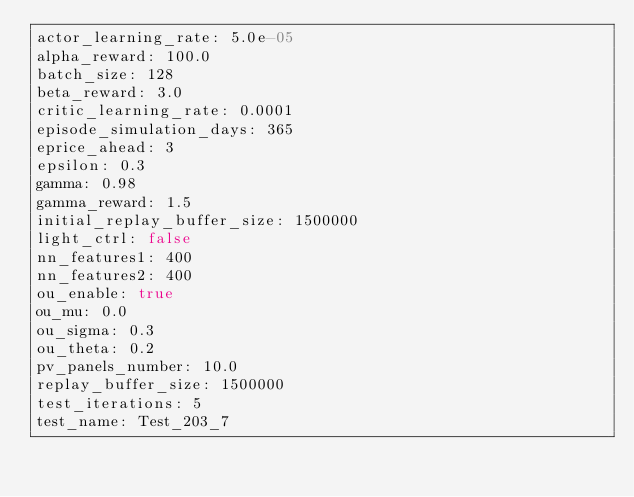Convert code to text. <code><loc_0><loc_0><loc_500><loc_500><_YAML_>actor_learning_rate: 5.0e-05
alpha_reward: 100.0
batch_size: 128
beta_reward: 3.0
critic_learning_rate: 0.0001
episode_simulation_days: 365
eprice_ahead: 3
epsilon: 0.3
gamma: 0.98
gamma_reward: 1.5
initial_replay_buffer_size: 1500000
light_ctrl: false
nn_features1: 400
nn_features2: 400
ou_enable: true
ou_mu: 0.0
ou_sigma: 0.3
ou_theta: 0.2
pv_panels_number: 10.0
replay_buffer_size: 1500000
test_iterations: 5
test_name: Test_203_7
</code> 